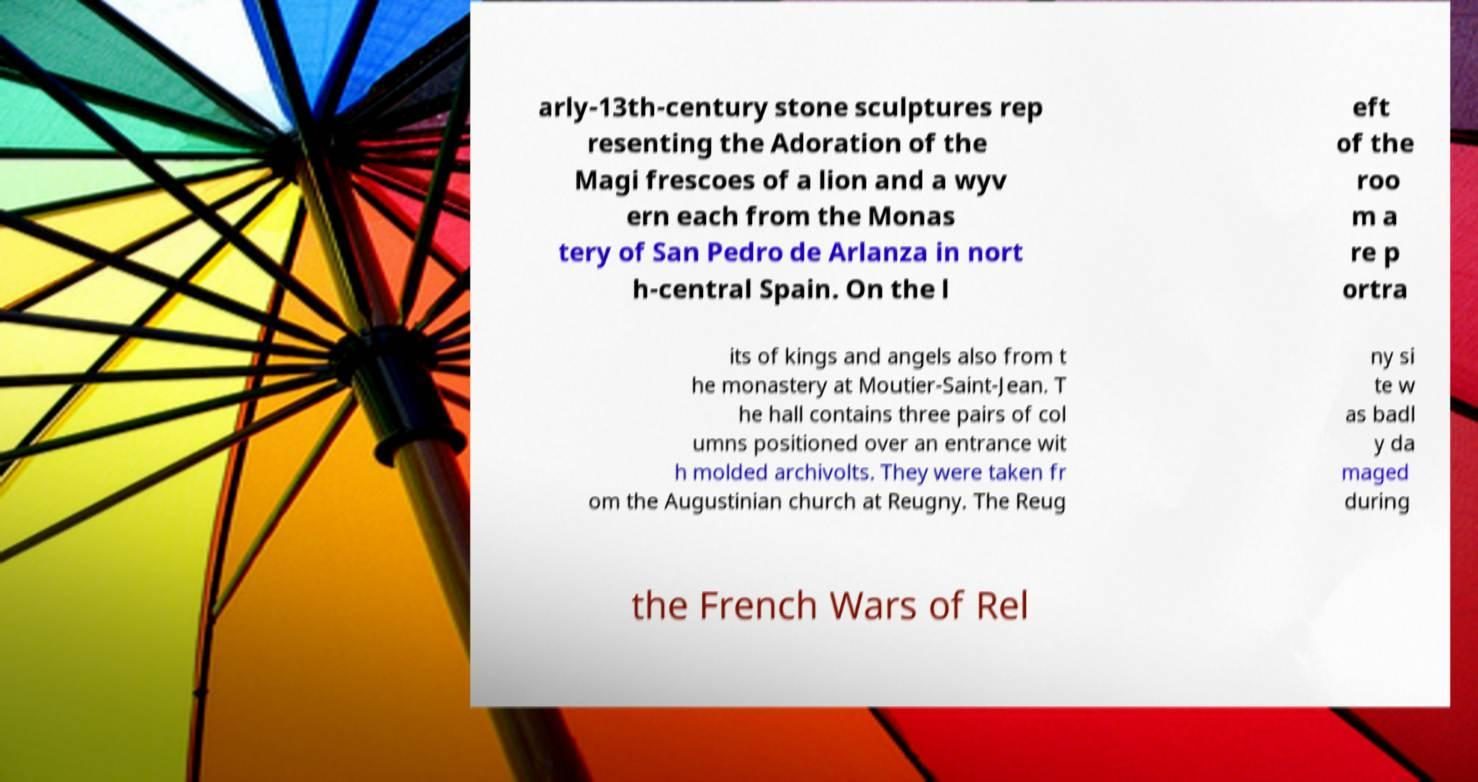There's text embedded in this image that I need extracted. Can you transcribe it verbatim? arly-13th-century stone sculptures rep resenting the Adoration of the Magi frescoes of a lion and a wyv ern each from the Monas tery of San Pedro de Arlanza in nort h-central Spain. On the l eft of the roo m a re p ortra its of kings and angels also from t he monastery at Moutier-Saint-Jean. T he hall contains three pairs of col umns positioned over an entrance wit h molded archivolts. They were taken fr om the Augustinian church at Reugny. The Reug ny si te w as badl y da maged during the French Wars of Rel 